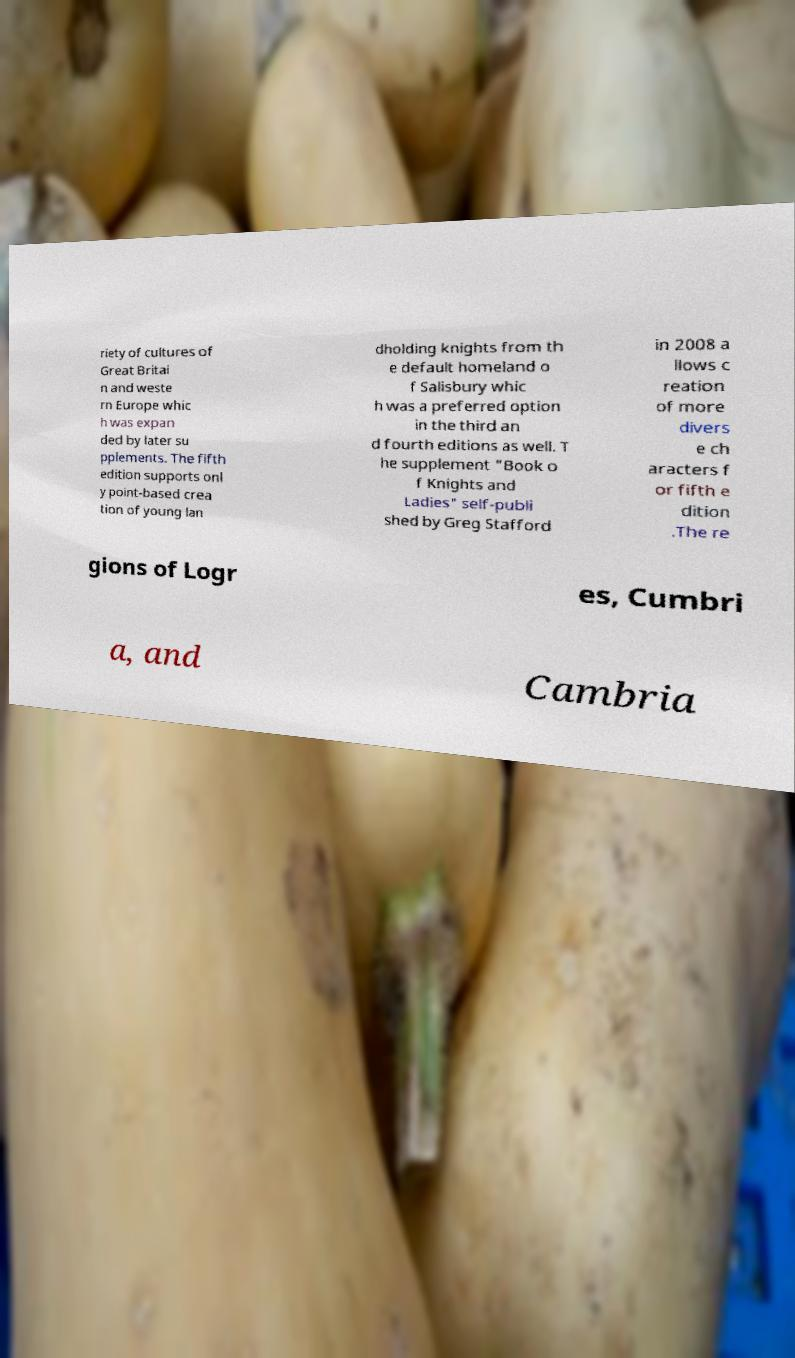There's text embedded in this image that I need extracted. Can you transcribe it verbatim? riety of cultures of Great Britai n and weste rn Europe whic h was expan ded by later su pplements. The fifth edition supports onl y point-based crea tion of young lan dholding knights from th e default homeland o f Salisbury whic h was a preferred option in the third an d fourth editions as well. T he supplement "Book o f Knights and Ladies" self-publi shed by Greg Stafford in 2008 a llows c reation of more divers e ch aracters f or fifth e dition .The re gions of Logr es, Cumbri a, and Cambria 